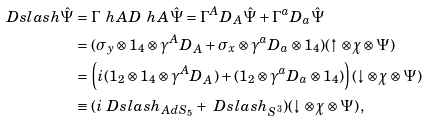<formula> <loc_0><loc_0><loc_500><loc_500>\ D s l a s h \hat { \Psi } & = \Gamma ^ { \ } h A D _ { \ } h A \hat { \Psi } = \Gamma ^ { A } D _ { A } \hat { \Psi } + \Gamma ^ { a } D _ { a } \hat { \Psi } \\ & = ( \sigma _ { y } \otimes 1 _ { 4 } \otimes \gamma ^ { A } D _ { A } + \sigma _ { x } \otimes \gamma ^ { a } D _ { a } \otimes 1 _ { 4 } ) ( \uparrow \otimes \chi \otimes \Psi ) \\ & = \left ( i ( 1 _ { 2 } \otimes 1 _ { 4 } \otimes \gamma ^ { A } D _ { A } ) + ( 1 _ { 2 } \otimes \gamma ^ { a } D _ { a } \otimes 1 _ { 4 } ) \right ) ( \downarrow \otimes \chi \otimes \Psi ) \\ & \equiv ( i \ D s l a s h _ { A d S _ { 5 } } + \ D s l a s h _ { S ^ { 3 } } ) ( \downarrow \otimes \chi \otimes \Psi ) \, ,</formula> 